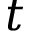<formula> <loc_0><loc_0><loc_500><loc_500>t</formula> 